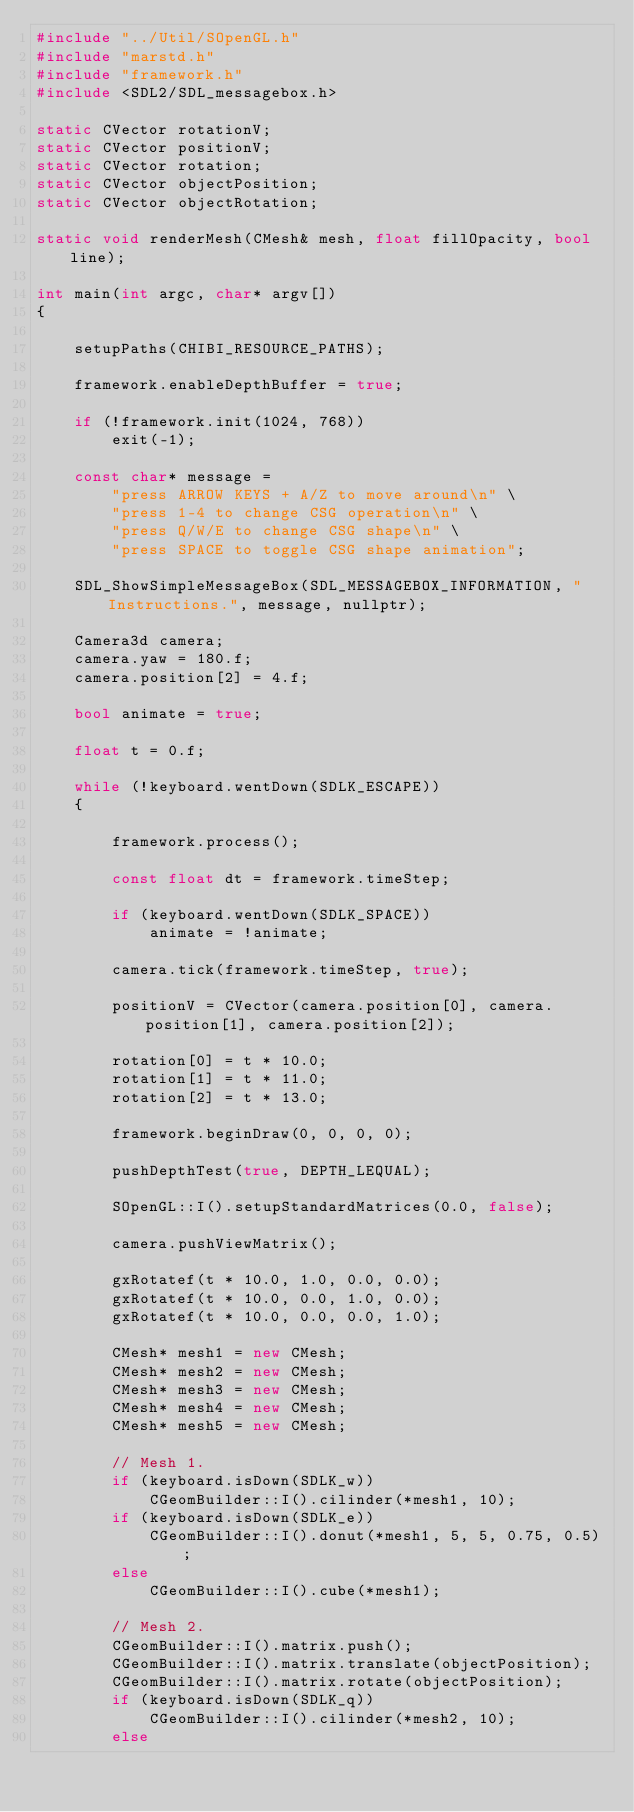Convert code to text. <code><loc_0><loc_0><loc_500><loc_500><_C++_>#include "../Util/SOpenGL.h"
#include "marstd.h"
#include "framework.h"
#include <SDL2/SDL_messagebox.h>

static CVector rotationV;
static CVector positionV;
static CVector rotation;
static CVector objectPosition;
static CVector objectRotation;

static void renderMesh(CMesh& mesh, float fillOpacity, bool line);

int main(int argc, char* argv[])
{

	setupPaths(CHIBI_RESOURCE_PATHS);

	framework.enableDepthBuffer = true;
	
	if (!framework.init(1024, 768))
		exit(-1);

	const char* message =
		"press ARROW KEYS + A/Z to move around\n" \
		"press 1-4 to change CSG operation\n" \
		"press Q/W/E to change CSG shape\n" \
		"press SPACE to toggle CSG shape animation";
	
	SDL_ShowSimpleMessageBox(SDL_MESSAGEBOX_INFORMATION, "Instructions.", message, nullptr);
	
	Camera3d camera;
	camera.yaw = 180.f;
	camera.position[2] = 4.f;
	
	bool animate = true;

	float t = 0.f;
	
	while (!keyboard.wentDown(SDLK_ESCAPE))
	{

		framework.process();
		
		const float dt = framework.timeStep;

		if (keyboard.wentDown(SDLK_SPACE))
			animate = !animate;
	
		camera.tick(framework.timeStep, true);
		
		positionV = CVector(camera.position[0], camera.position[1], camera.position[2]);
	
		rotation[0] = t * 10.0;
		rotation[1] = t * 11.0;
		rotation[2] = t * 13.0;

		framework.beginDraw(0, 0, 0, 0);

		pushDepthTest(true, DEPTH_LEQUAL);

		SOpenGL::I().setupStandardMatrices(0.0, false);
		
		camera.pushViewMatrix();
		
		gxRotatef(t * 10.0, 1.0, 0.0, 0.0);
		gxRotatef(t * 10.0, 0.0, 1.0, 0.0);
		gxRotatef(t * 10.0, 0.0, 0.0, 1.0);

		CMesh* mesh1 = new CMesh;
		CMesh* mesh2 = new CMesh;
		CMesh* mesh3 = new CMesh;
		CMesh* mesh4 = new CMesh;		
		CMesh* mesh5 = new CMesh;				
		
		// Mesh 1.
		if (keyboard.isDown(SDLK_w))
			CGeomBuilder::I().cilinder(*mesh1, 10);
		if (keyboard.isDown(SDLK_e))
			CGeomBuilder::I().donut(*mesh1, 5, 5, 0.75, 0.5);
		else
			CGeomBuilder::I().cube(*mesh1);
		
		// Mesh 2.
		CGeomBuilder::I().matrix.push();
		CGeomBuilder::I().matrix.translate(objectPosition);
		CGeomBuilder::I().matrix.rotate(objectPosition);
		if (keyboard.isDown(SDLK_q))
			CGeomBuilder::I().cilinder(*mesh2, 10);
		else</code> 